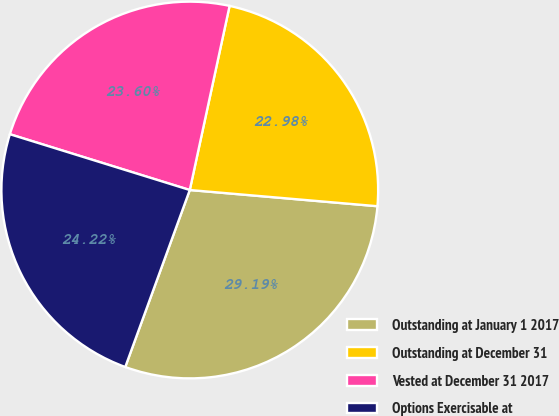<chart> <loc_0><loc_0><loc_500><loc_500><pie_chart><fcel>Outstanding at January 1 2017<fcel>Outstanding at December 31<fcel>Vested at December 31 2017<fcel>Options Exercisable at<nl><fcel>29.19%<fcel>22.98%<fcel>23.6%<fcel>24.22%<nl></chart> 